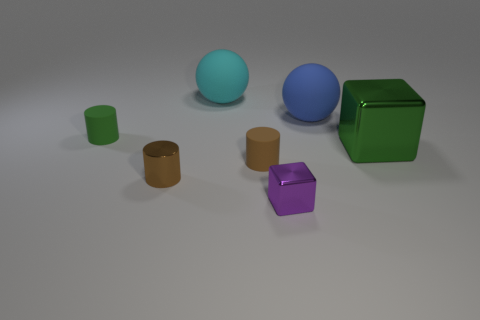Add 1 big matte spheres. How many objects exist? 8 Subtract all balls. How many objects are left? 5 Subtract all yellow matte things. Subtract all green cylinders. How many objects are left? 6 Add 4 big cyan rubber things. How many big cyan rubber things are left? 5 Add 2 big rubber balls. How many big rubber balls exist? 4 Subtract 0 blue cylinders. How many objects are left? 7 